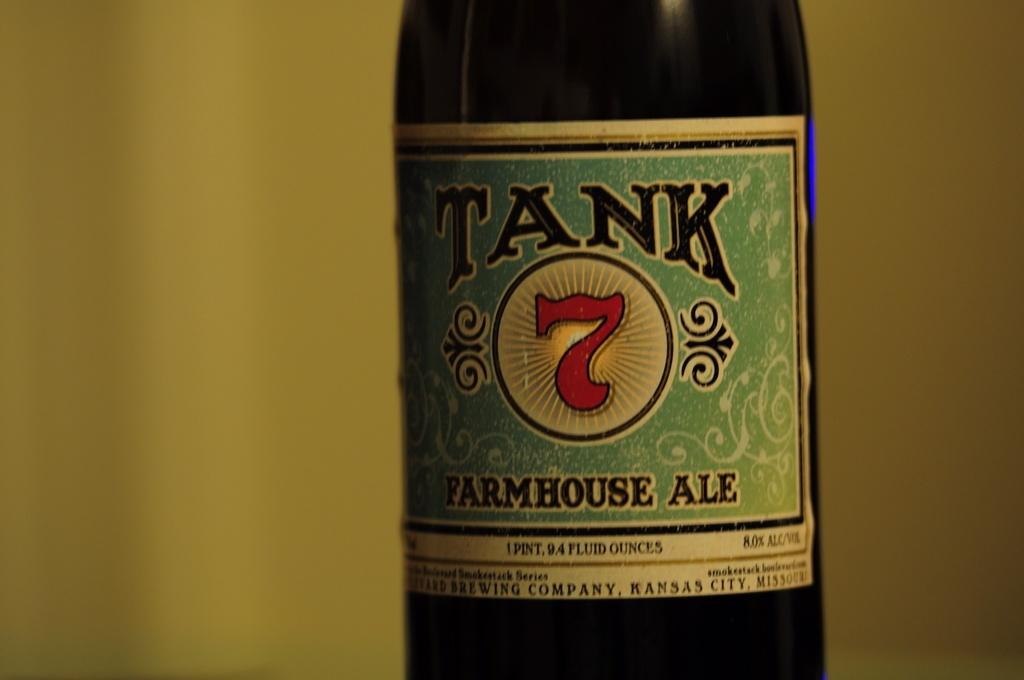<image>
Create a compact narrative representing the image presented. A bottle of Tank 7 farmhouse ale against a yellow backdrop. 